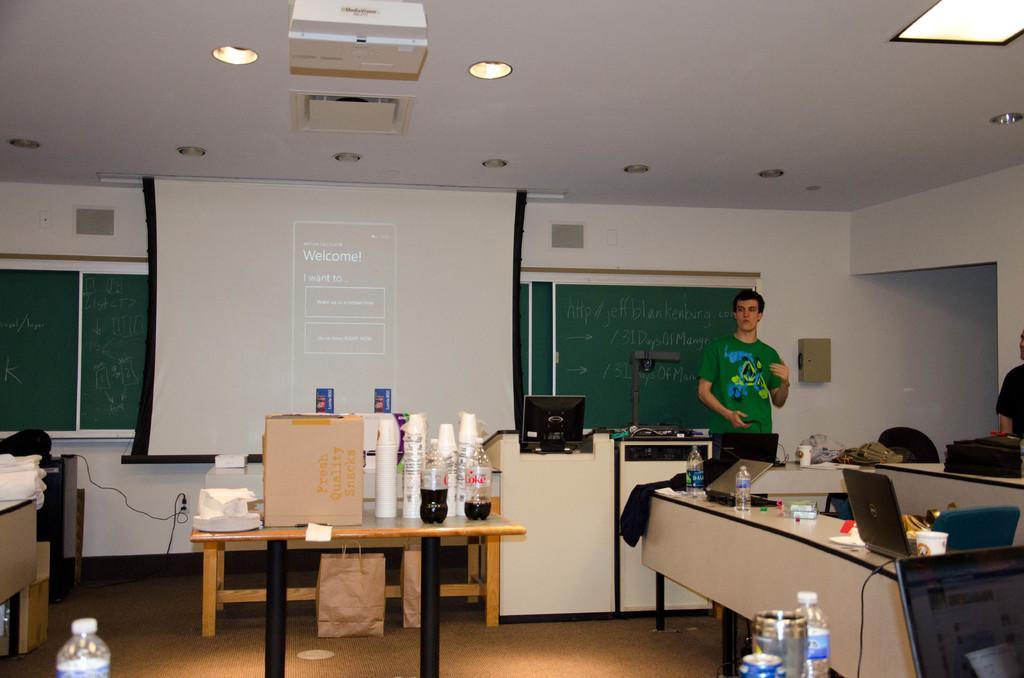Can you describe this image briefly? In this picture we can observe a person standing wearing a green color T shirt. There is a table on which we can observe glasses and two coke bottles. There is a box on the table. On the right side we can observe some laptops water bottles placed on the desk. We can observe a projector display screen. In the background there are green color boards and a computer. 